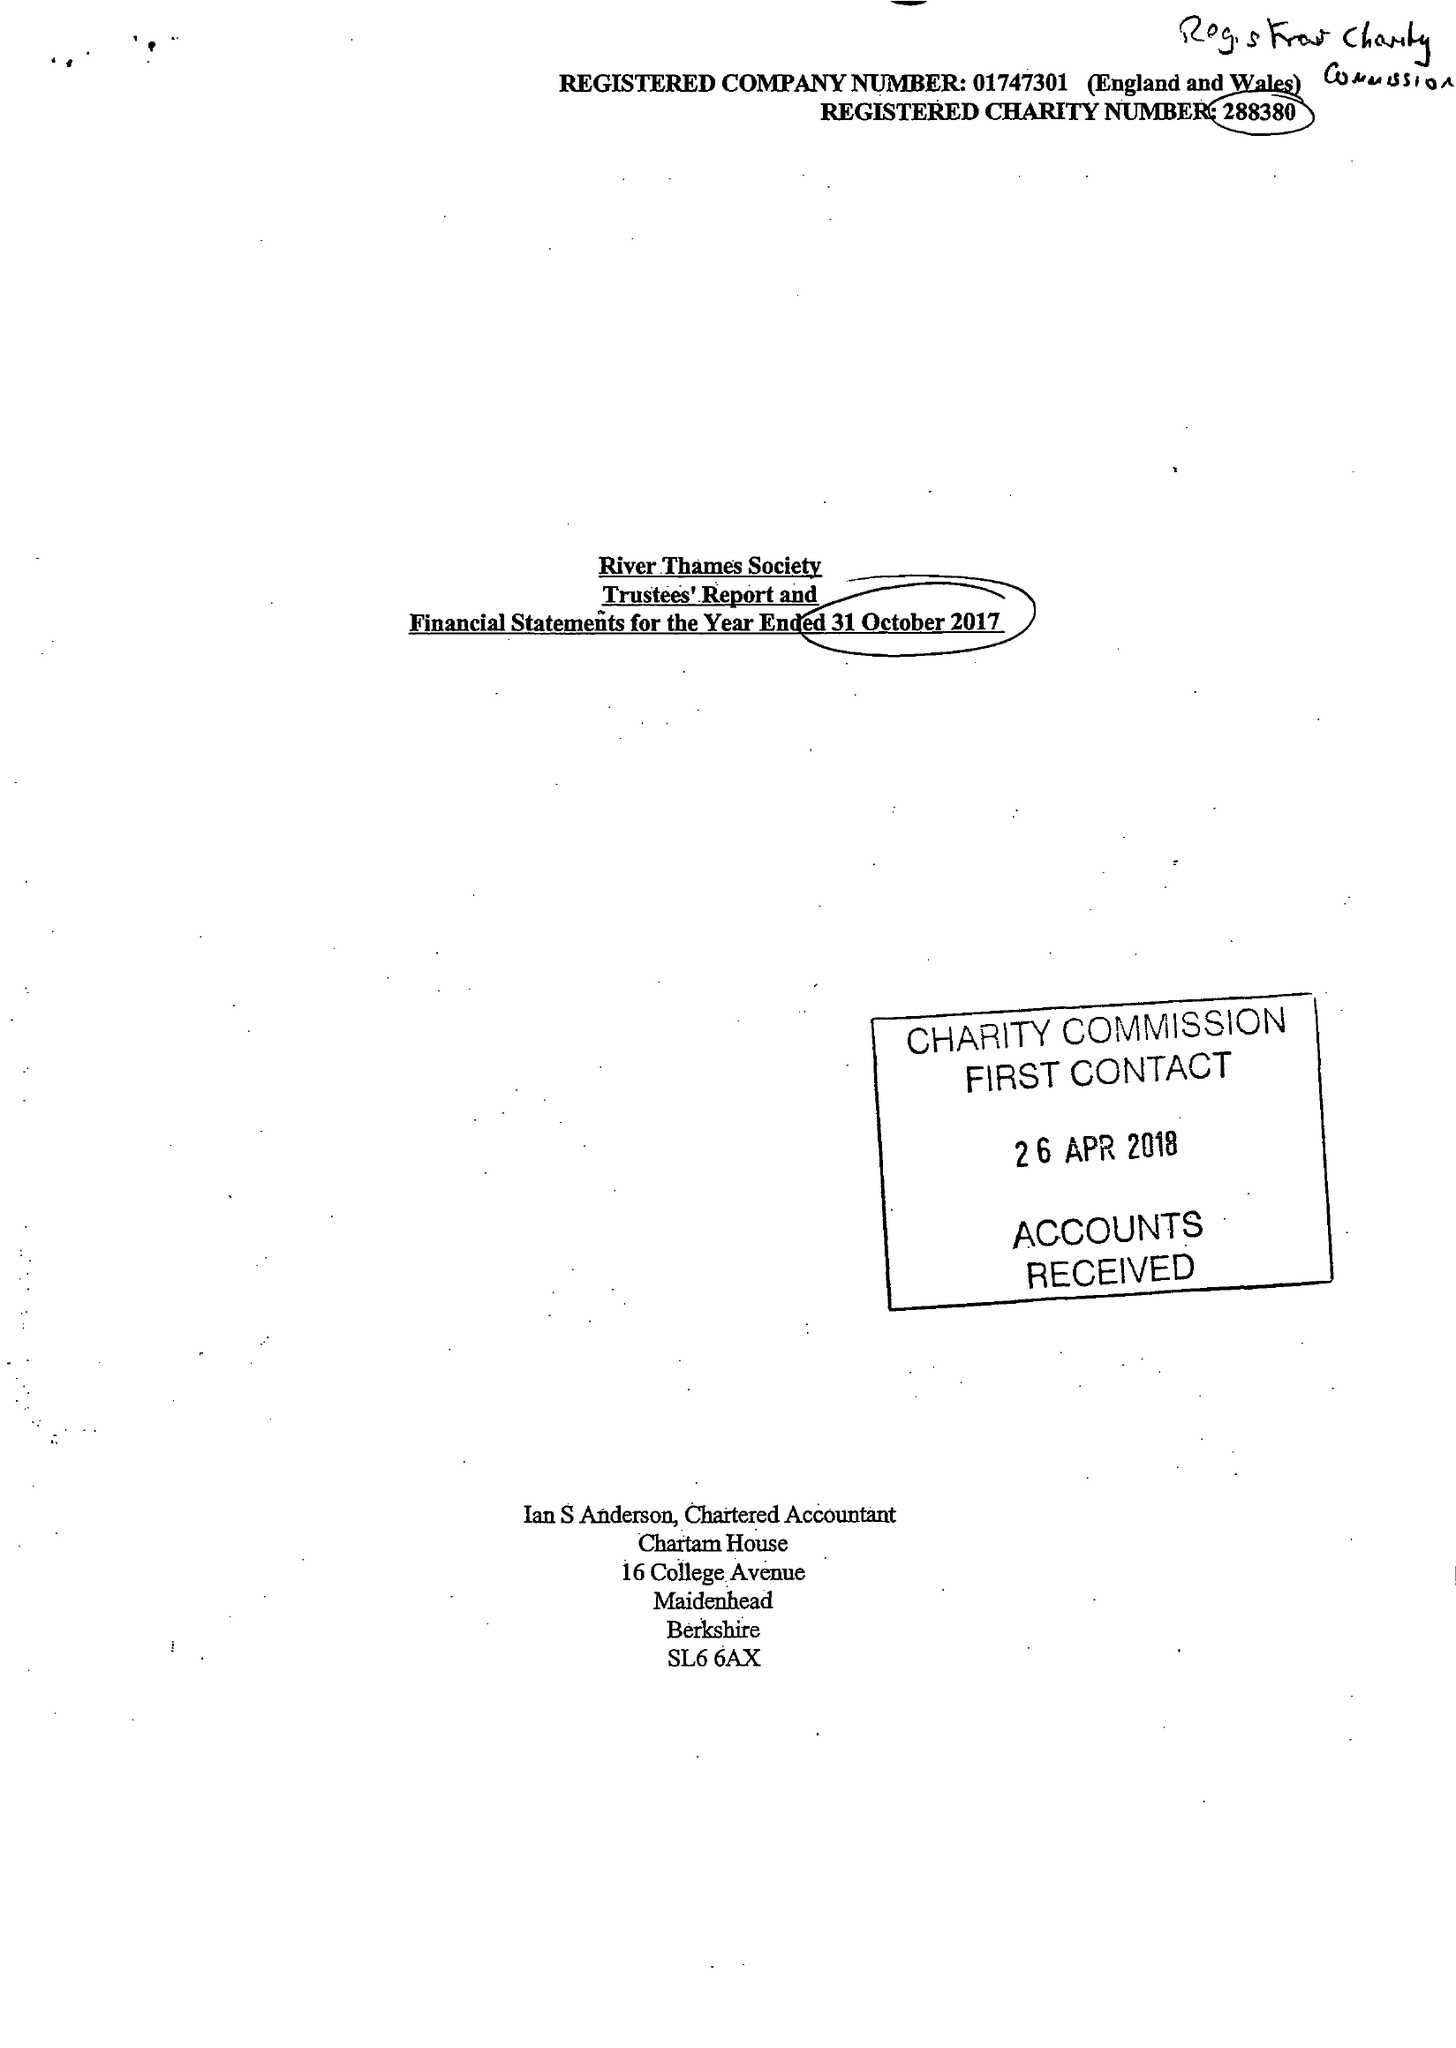What is the value for the address__post_town?
Answer the question using a single word or phrase. WINDSOR 